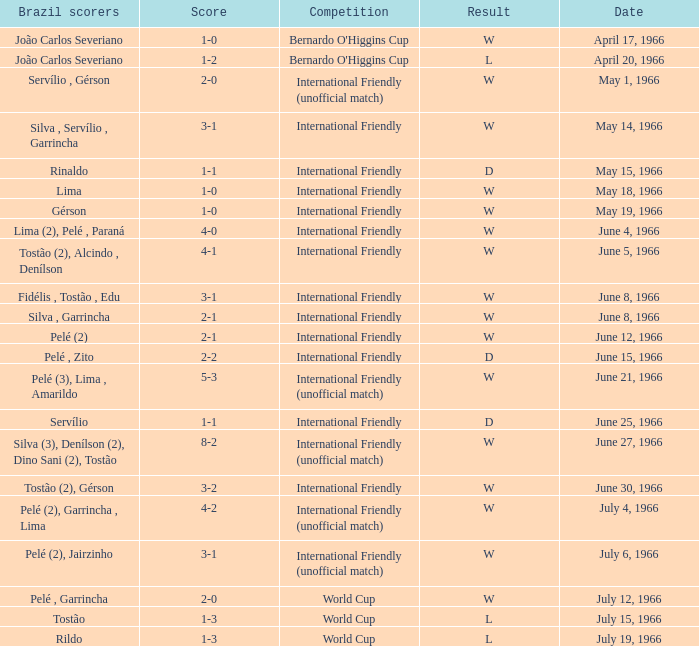What is the result of the International Friendly competition on May 15, 1966? D. 